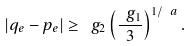<formula> <loc_0><loc_0><loc_500><loc_500>| q _ { e } - p _ { e } | \geq \ g _ { 2 } \left ( \frac { \ g _ { 1 } } { 3 } \right ) ^ { 1 / \ a } .</formula> 